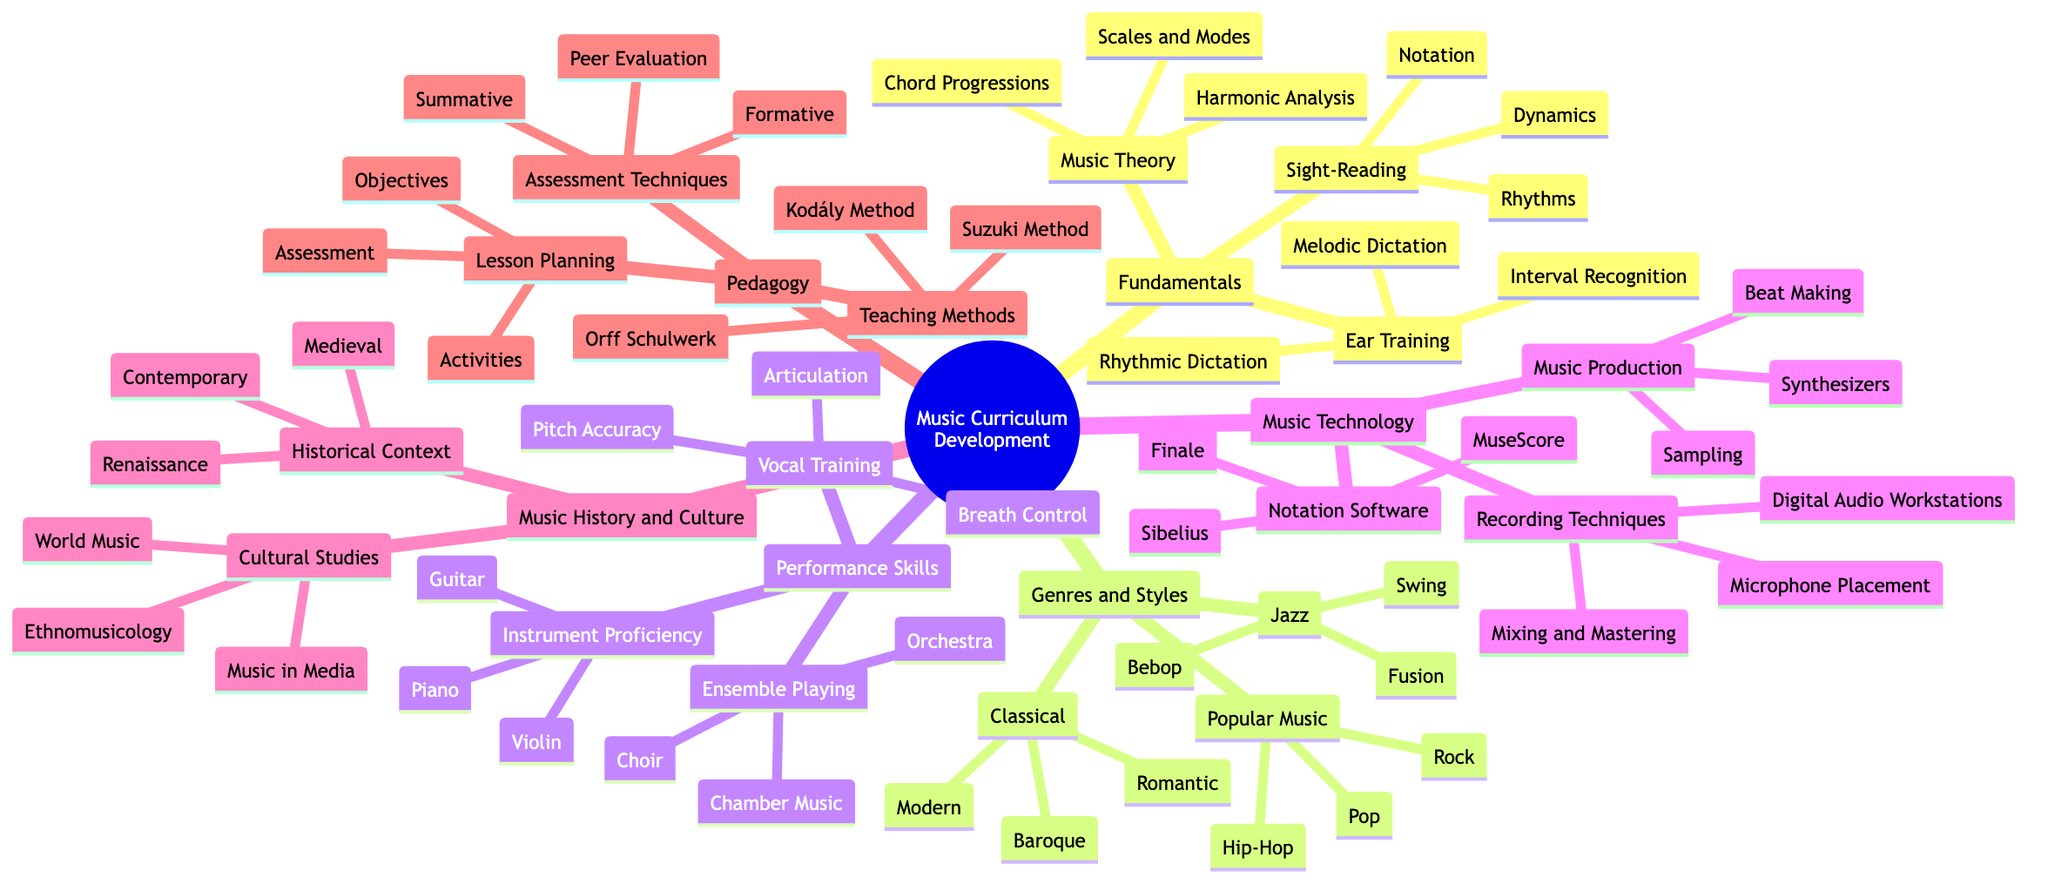What are the three components of Music Theory in the Fundamentals section? The diagram lists "Scales and Modes," "Chord Progressions," and "Harmonic Analysis" as the three components under the Music Theory category in Fundamentals. By directly examining the node labeled Fundamentals and identifying its sub-nodes, I can see these three terms.
Answer: Scales and Modes, Chord Progressions, Harmonic Analysis How many genres are listed in the Genres and Styles section? The Genres and Styles section contains three main categories: Classical, Jazz, and Popular Music. Each category further lists various styles. Thus, I count three main genres defined in this section.
Answer: 3 What is one example of a teaching method in the Pedagogy section? Looking at the Pedagogy node, I observe "Kodály Method," "Orff Schulwerk," and "Suzuki Method" listed as teaching methods. I can choose any of these examples; for simplicity, I select the first listed.
Answer: Kodály Method Which performance skill involves 'Breath Control'? "Breath Control" is a component of Vocal Training under the Performance Skills section. Tracing the diagram from Performance Skills down to Vocal Training, I find the answer clearly under that category.
Answer: Vocal Training What are the two components of Music Production in the Music Technology section? Referring to the Music Technology node, I see the section for Music Production, which includes "Synthesizers," "Beat Making," and "Sampling." Therefore, the components are clearly laid out, and I can directly list out two of them.
Answer: Synthesizers, Beat Making What does the Music History and Culture section include regarding Historical Context? Under the Music History and Culture category, there is a subcategory called Historical Context, which includes "Medieval," "Renaissance," and "Contemporary." I focus on this subcategory to answer the question.
Answer: Medieval, Renaissance, Contemporary How many instruments are listed under Instrument Proficiency? The Instrument Proficiency component recognizes three instruments: "Piano," "Guitar," and "Violin." By navigating to the Performance Skills node and counting the items under Instrument Proficiency, I establish that there are three distinct instruments listed.
Answer: 3 Which assessment technique is categorized as Summative? The diagram indicates that Summative is positioned under the Assessment Techniques in the Pedagogy section. This is a straightforward search since it’s clearly labeled and directly identified under the assessments in pedagogy.
Answer: Summative What is one example of a genre within Popular Music? Under the Popular Music category, I find examples such as "Rock," "Pop," and "Hip-Hop." By looking at the Popular Music node, I can clearly extract any one of these genres as an answer.
Answer: Rock 